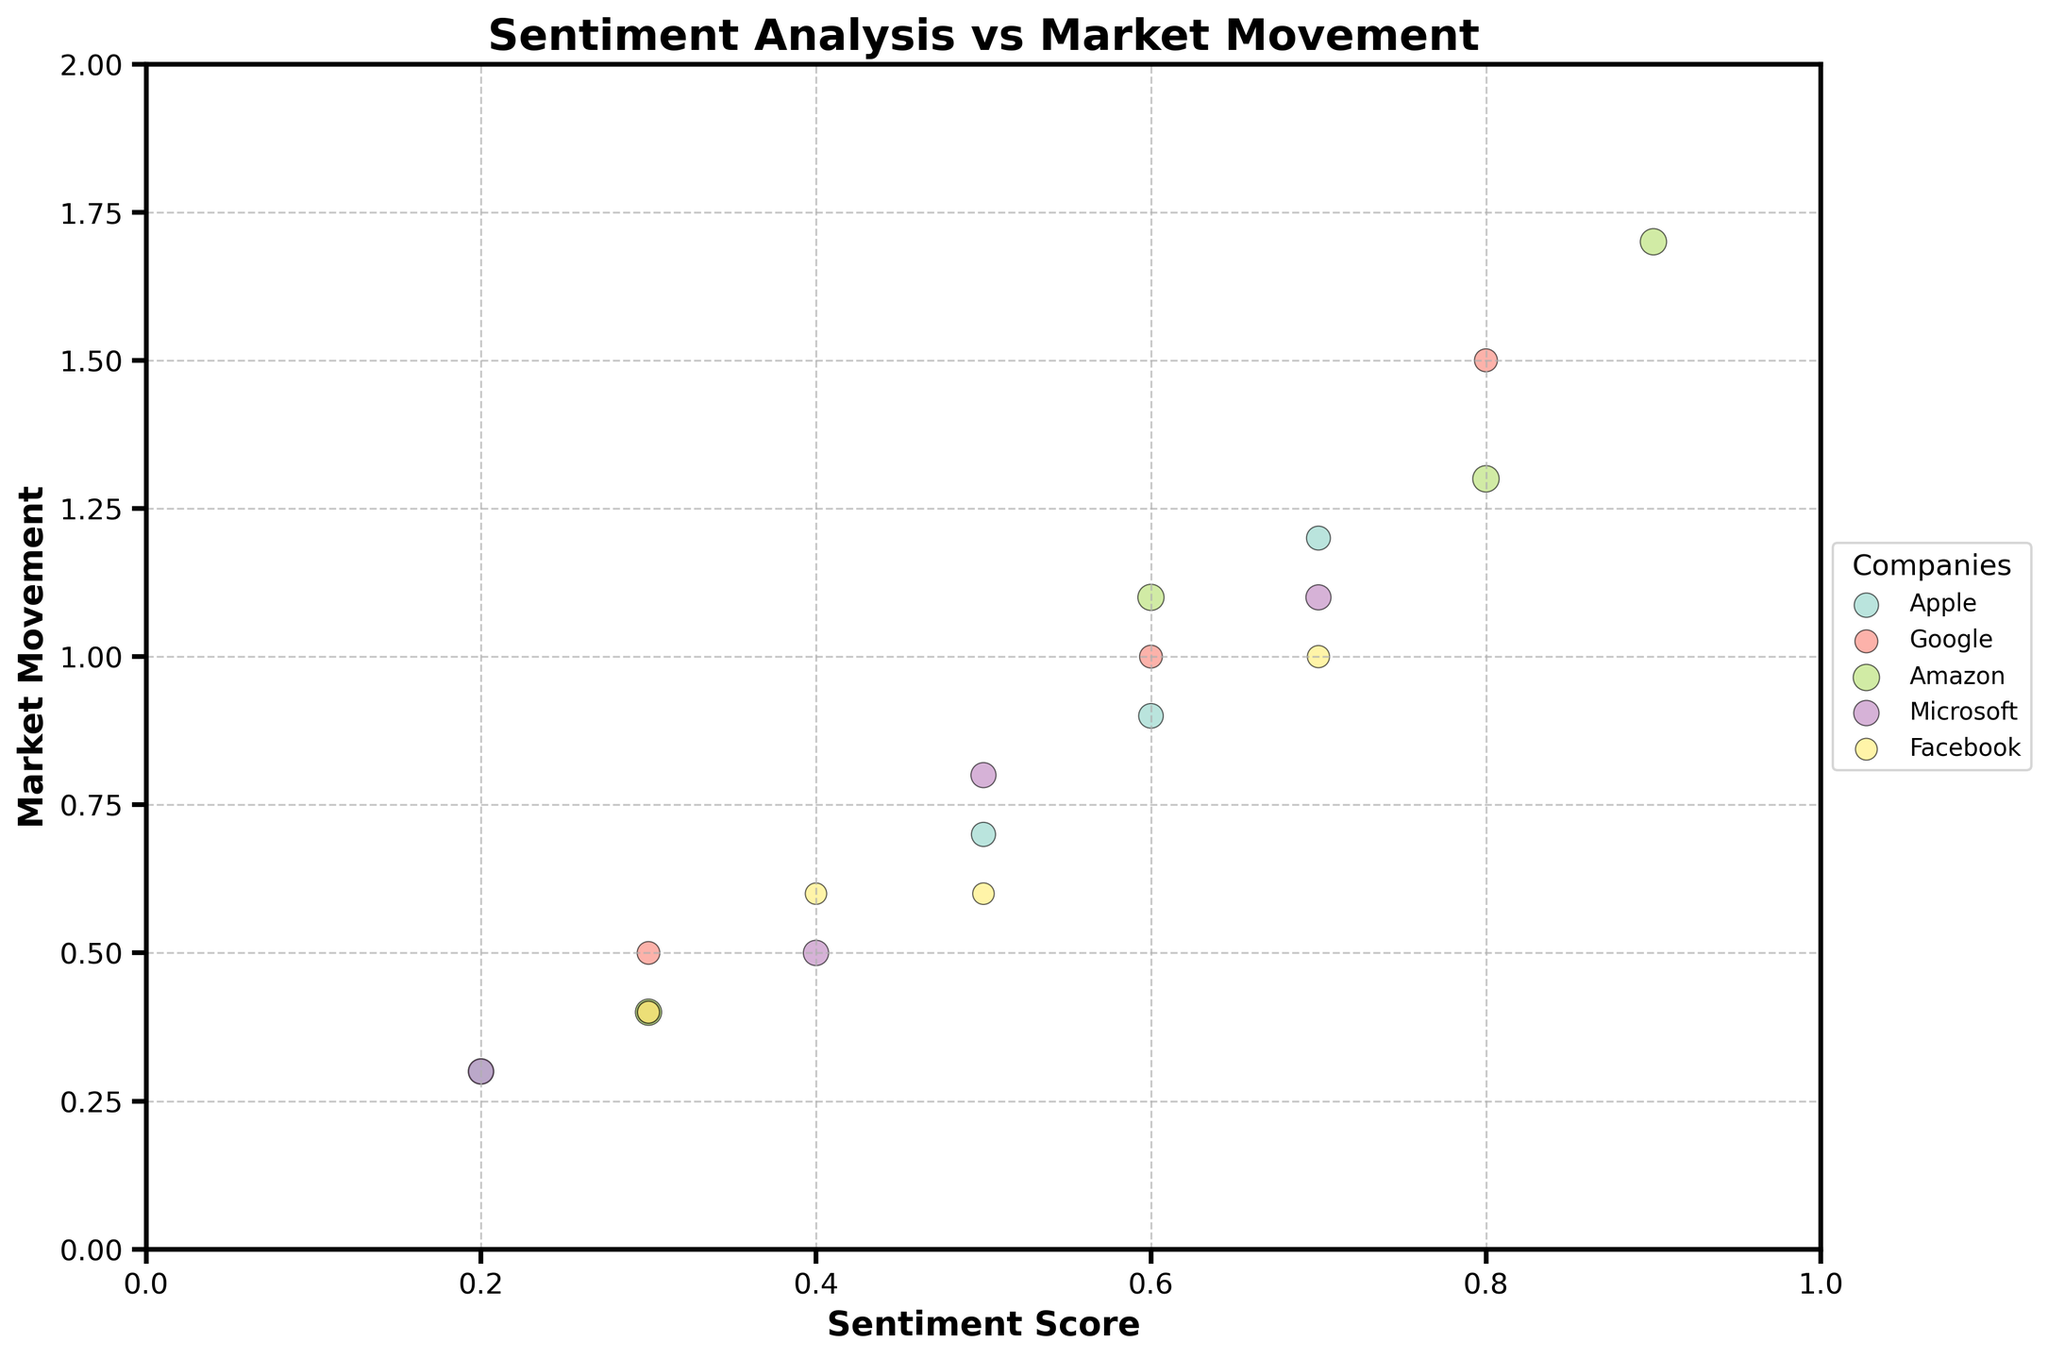What's the title of the chart? The title is written prominently at the top of the chart, indicating the overall focus of the visual representation. Reading the title directly provides the answer.
Answer: Sentiment Analysis vs Market Movement Which company has the highest sentiment score in February 2023? By looking at the data points for February 2023 and comparing the sentiment scores, you can identify the highest value.
Answer: Amazon Which company shows bubbles with the largest size, and what does the size represent? The size of the bubbles represents volume. By comparing the relative sizes of the bubbles, you can determine which company has the largest bubbles and what attribute they signify.
Answer: Amazon; Volume How many companies had a market movement greater than 1.0 in March 2023? By examining the data points for March 2023 and noting the values of market movement greater than 1.0, you can count the relevant points.
Answer: 1 company (Microsoft) Which month did Apple have the lowest sentiment score, and what was it? By examining the data points corresponding to Apple and comparing the sentiment scores for different months, you can identify the lowest value and the month it occurred.
Answer: February 2023; 0.2 Compare the market movement for Google in January and February 2023. Which month had a higher value, and by how much? By comparing the market movement values for Google in January and February, you can subtract the smaller value from the larger one to determine the difference.
Answer: February 2023; 1.0 higher What is the range of sentiment scores for Facebook across all months? By identifying the minimum and maximum sentiment scores for Facebook, you can subtract the smallest value from the largest to find the range.
Answer: Range is 0.4 (0.3 to 0.7) Which company has the most scattered points in terms of sentiment scores over the months? By visually inspecting the distribution of data points for each company, you can identify which company shows the most variation in sentiment scores over time.
Answer: Amazon Is there a positive correlation between sentiment scores and market movements? By examining the general trend of data points from left to right, check if higher sentiment scores are associated with higher market movement values.
Answer: Yes What is the average market movement for Microsoft in the dataset? Sum all market movement values for Microsoft and divide by the number of data points to calculate the average.
Answer: 0.675 